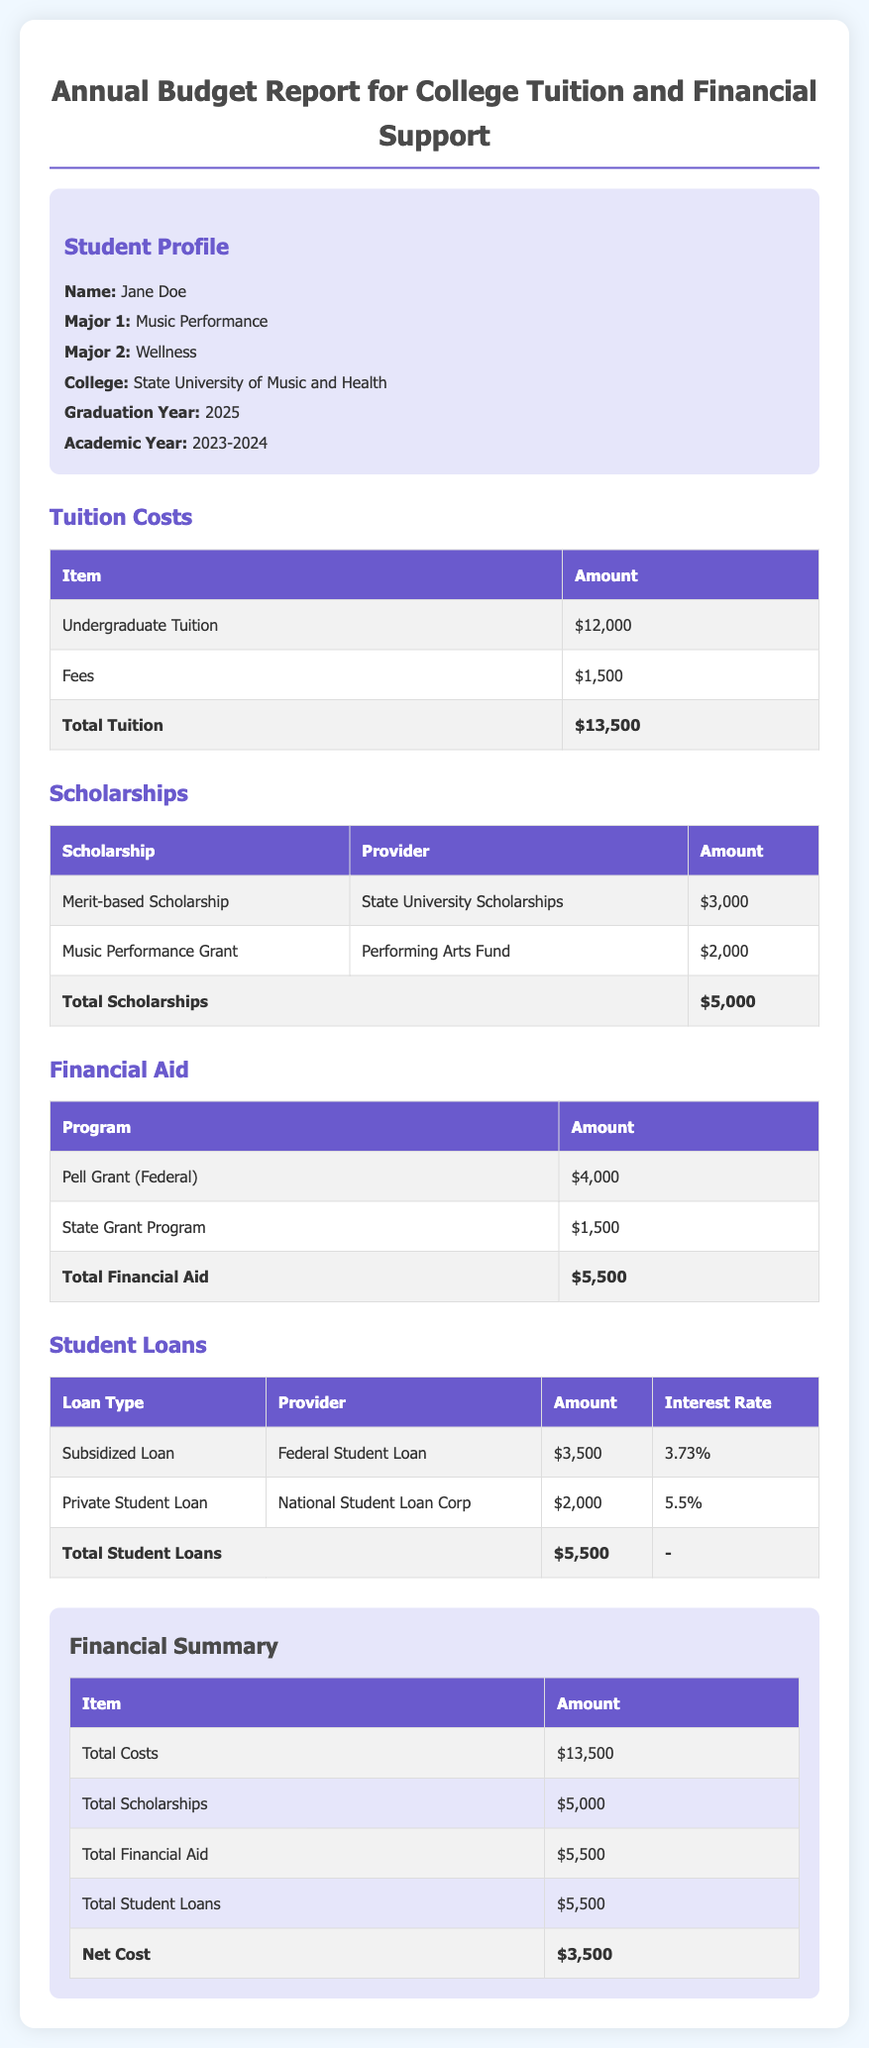What is the total tuition cost? The total tuition cost is summarized in the tuition section of the report, which lists undergraduate tuition and fees summing to $13,500.
Answer: $13,500 How much is the merit-based scholarship? The merit-based scholarship is listed in the scholarships section of the document, specifically as $3,000.
Answer: $3,000 What is the total financial aid amount? The total financial aid amount is derived from the financial aid section, which is the sum of Pell Grant and State Grant Program totaling $5,500.
Answer: $5,500 What types of student loans are listed? The document mentions two types of student loans: Subsidized Loan and Private Student Loan.
Answer: Subsidized Loan, Private Student Loan What is the net cost after accounting for scholarships and financial aid? The net cost is calculated by subtracting total scholarships and total financial aid from total tuition costs, resulting in $3,500.
Answer: $3,500 What is the total amount of scholarships? The document summarizes the total scholarships in the scholarships section, indicating a total of $5,000.
Answer: $5,000 Who provides the Music Performance Grant? The Music Performance Grant is provided by the Performing Arts Fund, as stated in the scholarships table.
Answer: Performing Arts Fund What does the total student loans amount to? The total student loans are calculated in the loans section, amounting to $5,500.
Answer: $5,500 How much is the state grant program worth? The state grant program amount is listed as $1,500 in the financial aid section of the report.
Answer: $1,500 